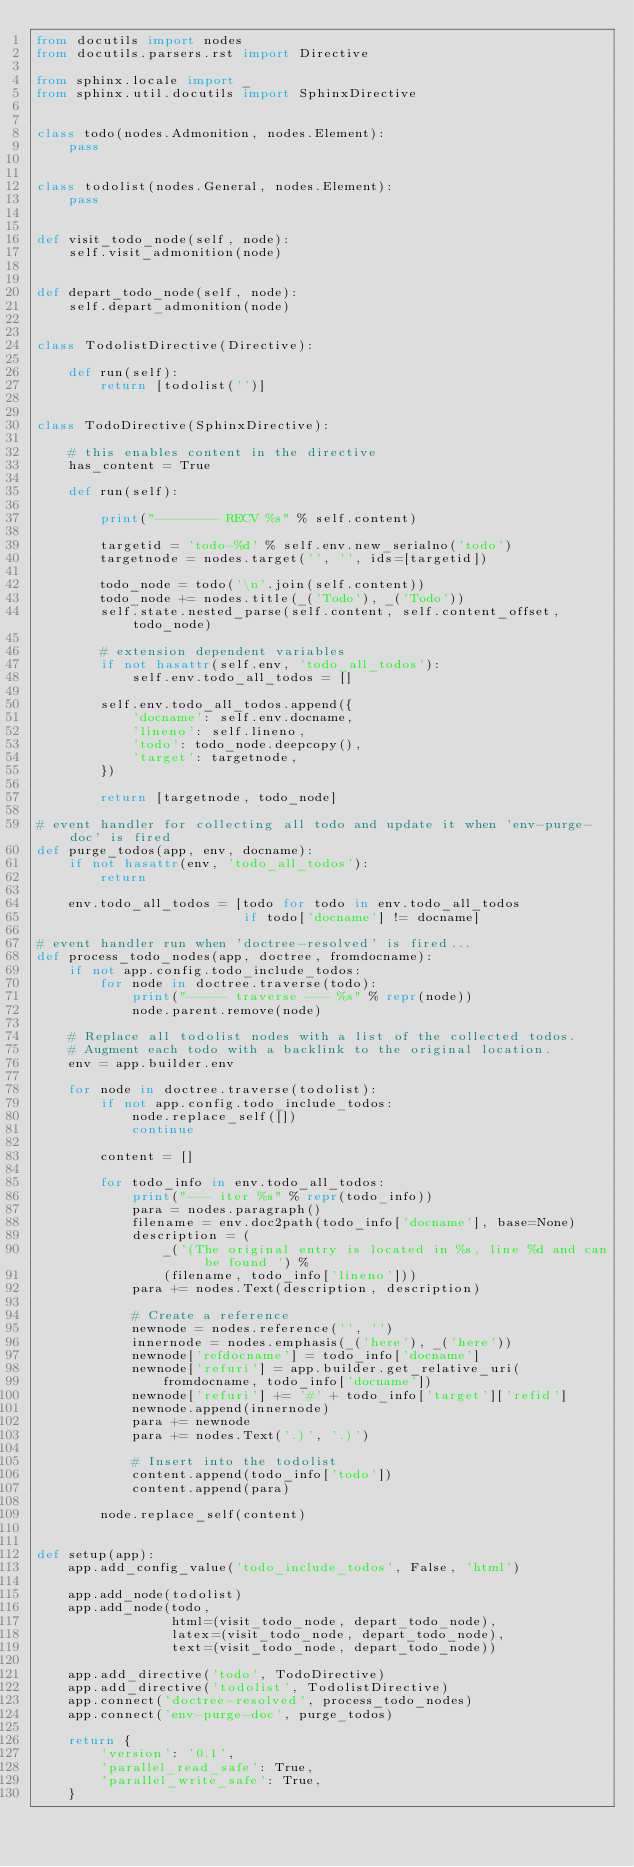Convert code to text. <code><loc_0><loc_0><loc_500><loc_500><_Python_>from docutils import nodes
from docutils.parsers.rst import Directive

from sphinx.locale import _
from sphinx.util.docutils import SphinxDirective


class todo(nodes.Admonition, nodes.Element):
    pass


class todolist(nodes.General, nodes.Element):
    pass


def visit_todo_node(self, node):
    self.visit_admonition(node)


def depart_todo_node(self, node):
    self.depart_admonition(node)


class TodolistDirective(Directive):

    def run(self):
        return [todolist('')]


class TodoDirective(SphinxDirective):

    # this enables content in the directive
    has_content = True

    def run(self):

        print("-------- RECV %s" % self.content)
    
        targetid = 'todo-%d' % self.env.new_serialno('todo')
        targetnode = nodes.target('', '', ids=[targetid])

        todo_node = todo('\n'.join(self.content))
        todo_node += nodes.title(_('Todo'), _('Todo'))
        self.state.nested_parse(self.content, self.content_offset, todo_node)

        # extension dependent variables
        if not hasattr(self.env, 'todo_all_todos'):
            self.env.todo_all_todos = []

        self.env.todo_all_todos.append({
            'docname': self.env.docname,
            'lineno': self.lineno,
            'todo': todo_node.deepcopy(),
            'target': targetnode,
        })

        return [targetnode, todo_node]

# event handler for collecting all todo and update it when 'env-purge-doc' is fired
def purge_todos(app, env, docname):
    if not hasattr(env, 'todo_all_todos'):
        return

    env.todo_all_todos = [todo for todo in env.todo_all_todos
                          if todo['docname'] != docname]

# event handler run when 'doctree-resolved' is fired... 
def process_todo_nodes(app, doctree, fromdocname):
    if not app.config.todo_include_todos:
        for node in doctree.traverse(todo):
            print("----- traverse --- %s" % repr(node))
            node.parent.remove(node)

    # Replace all todolist nodes with a list of the collected todos.
    # Augment each todo with a backlink to the original location.
    env = app.builder.env

    for node in doctree.traverse(todolist):
        if not app.config.todo_include_todos:
            node.replace_self([])
            continue

        content = []

        for todo_info in env.todo_all_todos:
            print("--- iter %s" % repr(todo_info))
            para = nodes.paragraph()
            filename = env.doc2path(todo_info['docname'], base=None)
            description = (
                _('(The original entry is located in %s, line %d and can be found ') %
                (filename, todo_info['lineno']))
            para += nodes.Text(description, description)

            # Create a reference
            newnode = nodes.reference('', '')
            innernode = nodes.emphasis(_('here'), _('here'))
            newnode['refdocname'] = todo_info['docname']
            newnode['refuri'] = app.builder.get_relative_uri(
                fromdocname, todo_info['docname'])
            newnode['refuri'] += '#' + todo_info['target']['refid']
            newnode.append(innernode)
            para += newnode
            para += nodes.Text('.)', '.)')

            # Insert into the todolist
            content.append(todo_info['todo'])
            content.append(para)

        node.replace_self(content)


def setup(app):
    app.add_config_value('todo_include_todos', False, 'html')

    app.add_node(todolist)
    app.add_node(todo,
                 html=(visit_todo_node, depart_todo_node),
                 latex=(visit_todo_node, depart_todo_node),
                 text=(visit_todo_node, depart_todo_node))

    app.add_directive('todo', TodoDirective)
    app.add_directive('todolist', TodolistDirective)
    app.connect('doctree-resolved', process_todo_nodes)
    app.connect('env-purge-doc', purge_todos)

    return {
        'version': '0.1',
        'parallel_read_safe': True,
        'parallel_write_safe': True,
    }
</code> 